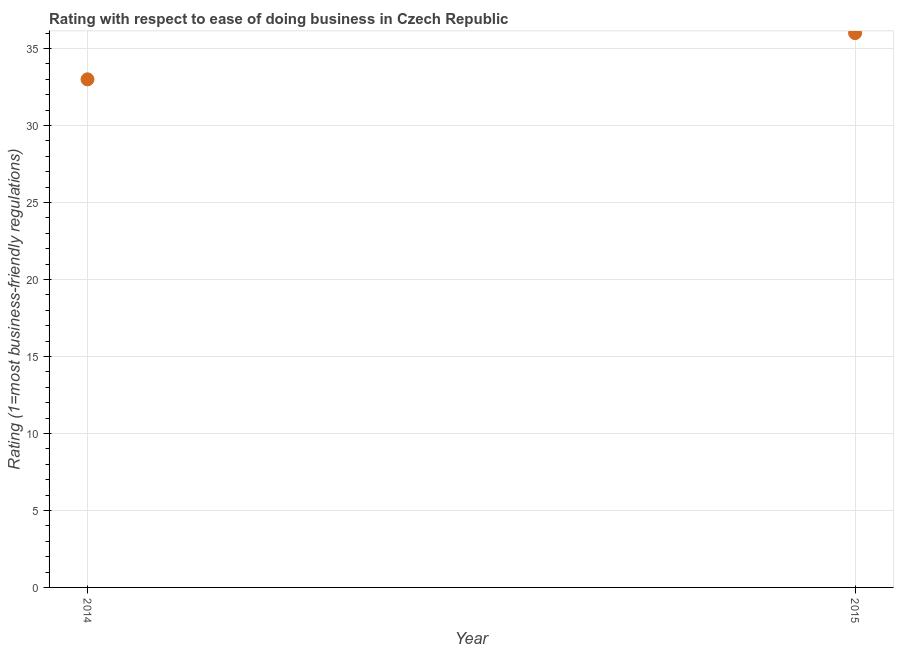What is the ease of doing business index in 2014?
Your answer should be very brief. 33. Across all years, what is the maximum ease of doing business index?
Offer a very short reply. 36. Across all years, what is the minimum ease of doing business index?
Your answer should be compact. 33. In which year was the ease of doing business index maximum?
Ensure brevity in your answer.  2015. What is the sum of the ease of doing business index?
Offer a terse response. 69. What is the difference between the ease of doing business index in 2014 and 2015?
Offer a very short reply. -3. What is the average ease of doing business index per year?
Your response must be concise. 34.5. What is the median ease of doing business index?
Your response must be concise. 34.5. What is the ratio of the ease of doing business index in 2014 to that in 2015?
Your response must be concise. 0.92. Does the ease of doing business index monotonically increase over the years?
Offer a terse response. Yes. How many dotlines are there?
Give a very brief answer. 1. How many years are there in the graph?
Offer a terse response. 2. What is the difference between two consecutive major ticks on the Y-axis?
Provide a short and direct response. 5. Are the values on the major ticks of Y-axis written in scientific E-notation?
Your answer should be compact. No. Does the graph contain grids?
Your response must be concise. Yes. What is the title of the graph?
Offer a terse response. Rating with respect to ease of doing business in Czech Republic. What is the label or title of the Y-axis?
Your answer should be compact. Rating (1=most business-friendly regulations). What is the Rating (1=most business-friendly regulations) in 2014?
Ensure brevity in your answer.  33. What is the Rating (1=most business-friendly regulations) in 2015?
Keep it short and to the point. 36. What is the ratio of the Rating (1=most business-friendly regulations) in 2014 to that in 2015?
Offer a terse response. 0.92. 